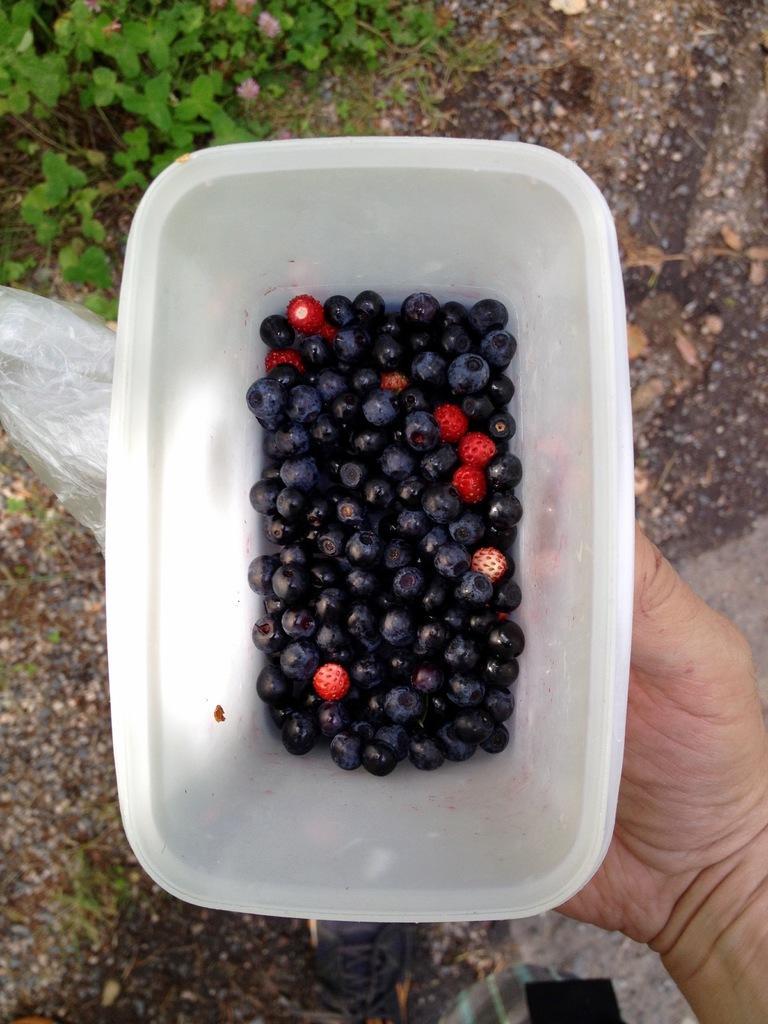Could you give a brief overview of what you see in this image? In this image in the center there are berries in the container. On the right side there is a hand holding the container. At the top there are leaves which are visible. 